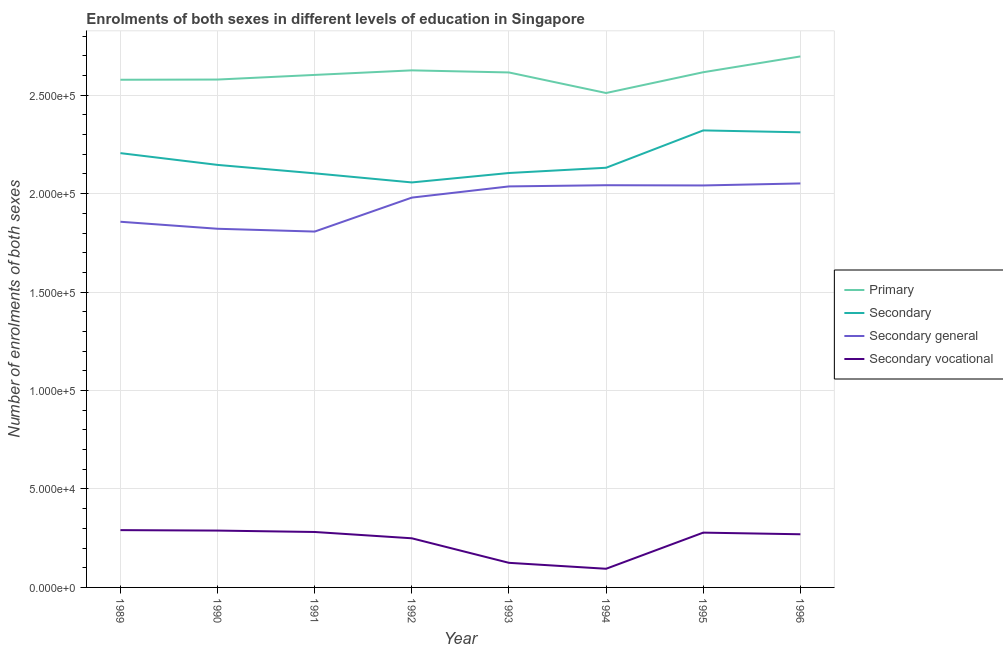Does the line corresponding to number of enrolments in secondary general education intersect with the line corresponding to number of enrolments in secondary education?
Keep it short and to the point. No. What is the number of enrolments in secondary vocational education in 1991?
Provide a succinct answer. 2.82e+04. Across all years, what is the maximum number of enrolments in primary education?
Keep it short and to the point. 2.70e+05. Across all years, what is the minimum number of enrolments in secondary vocational education?
Give a very brief answer. 9476. What is the total number of enrolments in secondary vocational education in the graph?
Provide a succinct answer. 1.88e+05. What is the difference between the number of enrolments in primary education in 1995 and that in 1996?
Offer a very short reply. -8020. What is the difference between the number of enrolments in primary education in 1991 and the number of enrolments in secondary vocational education in 1996?
Ensure brevity in your answer.  2.33e+05. What is the average number of enrolments in secondary general education per year?
Your answer should be compact. 1.95e+05. In the year 1996, what is the difference between the number of enrolments in secondary education and number of enrolments in secondary general education?
Ensure brevity in your answer.  2.60e+04. In how many years, is the number of enrolments in secondary education greater than 200000?
Offer a very short reply. 8. What is the ratio of the number of enrolments in secondary education in 1994 to that in 1995?
Ensure brevity in your answer.  0.92. What is the difference between the highest and the second highest number of enrolments in primary education?
Provide a short and direct response. 7069. What is the difference between the highest and the lowest number of enrolments in secondary education?
Provide a succinct answer. 2.64e+04. In how many years, is the number of enrolments in secondary general education greater than the average number of enrolments in secondary general education taken over all years?
Offer a terse response. 5. Is the sum of the number of enrolments in secondary education in 1990 and 1991 greater than the maximum number of enrolments in primary education across all years?
Provide a succinct answer. Yes. Is it the case that in every year, the sum of the number of enrolments in secondary general education and number of enrolments in secondary vocational education is greater than the sum of number of enrolments in primary education and number of enrolments in secondary education?
Provide a short and direct response. No. Does the number of enrolments in primary education monotonically increase over the years?
Provide a succinct answer. No. Is the number of enrolments in primary education strictly less than the number of enrolments in secondary general education over the years?
Keep it short and to the point. No. How many lines are there?
Provide a succinct answer. 4. How many years are there in the graph?
Provide a succinct answer. 8. Are the values on the major ticks of Y-axis written in scientific E-notation?
Provide a succinct answer. Yes. Does the graph contain any zero values?
Your answer should be very brief. No. Does the graph contain grids?
Make the answer very short. Yes. What is the title of the graph?
Give a very brief answer. Enrolments of both sexes in different levels of education in Singapore. Does "Regional development banks" appear as one of the legend labels in the graph?
Provide a short and direct response. No. What is the label or title of the X-axis?
Give a very brief answer. Year. What is the label or title of the Y-axis?
Provide a short and direct response. Number of enrolments of both sexes. What is the Number of enrolments of both sexes of Primary in 1989?
Give a very brief answer. 2.58e+05. What is the Number of enrolments of both sexes in Secondary in 1989?
Your response must be concise. 2.21e+05. What is the Number of enrolments of both sexes of Secondary general in 1989?
Provide a succinct answer. 1.86e+05. What is the Number of enrolments of both sexes in Secondary vocational in 1989?
Your answer should be compact. 2.91e+04. What is the Number of enrolments of both sexes in Primary in 1990?
Offer a very short reply. 2.58e+05. What is the Number of enrolments of both sexes of Secondary in 1990?
Provide a short and direct response. 2.15e+05. What is the Number of enrolments of both sexes of Secondary general in 1990?
Your response must be concise. 1.82e+05. What is the Number of enrolments of both sexes of Secondary vocational in 1990?
Offer a terse response. 2.89e+04. What is the Number of enrolments of both sexes in Primary in 1991?
Ensure brevity in your answer.  2.60e+05. What is the Number of enrolments of both sexes of Secondary in 1991?
Offer a terse response. 2.10e+05. What is the Number of enrolments of both sexes of Secondary general in 1991?
Make the answer very short. 1.81e+05. What is the Number of enrolments of both sexes of Secondary vocational in 1991?
Provide a succinct answer. 2.82e+04. What is the Number of enrolments of both sexes in Primary in 1992?
Your answer should be very brief. 2.63e+05. What is the Number of enrolments of both sexes in Secondary in 1992?
Offer a terse response. 2.06e+05. What is the Number of enrolments of both sexes of Secondary general in 1992?
Your response must be concise. 1.98e+05. What is the Number of enrolments of both sexes in Secondary vocational in 1992?
Provide a succinct answer. 2.50e+04. What is the Number of enrolments of both sexes of Primary in 1993?
Provide a short and direct response. 2.62e+05. What is the Number of enrolments of both sexes of Secondary in 1993?
Provide a short and direct response. 2.10e+05. What is the Number of enrolments of both sexes of Secondary general in 1993?
Provide a succinct answer. 2.04e+05. What is the Number of enrolments of both sexes of Secondary vocational in 1993?
Make the answer very short. 1.25e+04. What is the Number of enrolments of both sexes in Primary in 1994?
Make the answer very short. 2.51e+05. What is the Number of enrolments of both sexes in Secondary in 1994?
Provide a short and direct response. 2.13e+05. What is the Number of enrolments of both sexes in Secondary general in 1994?
Provide a succinct answer. 2.04e+05. What is the Number of enrolments of both sexes in Secondary vocational in 1994?
Your answer should be compact. 9476. What is the Number of enrolments of both sexes of Primary in 1995?
Your answer should be very brief. 2.62e+05. What is the Number of enrolments of both sexes of Secondary in 1995?
Ensure brevity in your answer.  2.32e+05. What is the Number of enrolments of both sexes of Secondary general in 1995?
Your response must be concise. 2.04e+05. What is the Number of enrolments of both sexes of Secondary vocational in 1995?
Keep it short and to the point. 2.78e+04. What is the Number of enrolments of both sexes in Primary in 1996?
Your answer should be very brief. 2.70e+05. What is the Number of enrolments of both sexes in Secondary in 1996?
Provide a short and direct response. 2.31e+05. What is the Number of enrolments of both sexes of Secondary general in 1996?
Give a very brief answer. 2.05e+05. What is the Number of enrolments of both sexes in Secondary vocational in 1996?
Offer a very short reply. 2.70e+04. Across all years, what is the maximum Number of enrolments of both sexes of Primary?
Ensure brevity in your answer.  2.70e+05. Across all years, what is the maximum Number of enrolments of both sexes of Secondary?
Keep it short and to the point. 2.32e+05. Across all years, what is the maximum Number of enrolments of both sexes in Secondary general?
Make the answer very short. 2.05e+05. Across all years, what is the maximum Number of enrolments of both sexes in Secondary vocational?
Ensure brevity in your answer.  2.91e+04. Across all years, what is the minimum Number of enrolments of both sexes in Primary?
Your answer should be very brief. 2.51e+05. Across all years, what is the minimum Number of enrolments of both sexes of Secondary?
Make the answer very short. 2.06e+05. Across all years, what is the minimum Number of enrolments of both sexes in Secondary general?
Your answer should be very brief. 1.81e+05. Across all years, what is the minimum Number of enrolments of both sexes in Secondary vocational?
Offer a terse response. 9476. What is the total Number of enrolments of both sexes in Primary in the graph?
Offer a very short reply. 2.08e+06. What is the total Number of enrolments of both sexes in Secondary in the graph?
Ensure brevity in your answer.  1.74e+06. What is the total Number of enrolments of both sexes in Secondary general in the graph?
Ensure brevity in your answer.  1.56e+06. What is the total Number of enrolments of both sexes in Secondary vocational in the graph?
Give a very brief answer. 1.88e+05. What is the difference between the Number of enrolments of both sexes of Primary in 1989 and that in 1990?
Ensure brevity in your answer.  -99. What is the difference between the Number of enrolments of both sexes in Secondary in 1989 and that in 1990?
Make the answer very short. 5977. What is the difference between the Number of enrolments of both sexes in Secondary general in 1989 and that in 1990?
Your answer should be very brief. 3564. What is the difference between the Number of enrolments of both sexes of Secondary vocational in 1989 and that in 1990?
Offer a terse response. 231. What is the difference between the Number of enrolments of both sexes of Primary in 1989 and that in 1991?
Offer a terse response. -2453. What is the difference between the Number of enrolments of both sexes of Secondary in 1989 and that in 1991?
Ensure brevity in your answer.  1.03e+04. What is the difference between the Number of enrolments of both sexes in Secondary general in 1989 and that in 1991?
Offer a very short reply. 4984. What is the difference between the Number of enrolments of both sexes of Secondary vocational in 1989 and that in 1991?
Offer a terse response. 947. What is the difference between the Number of enrolments of both sexes of Primary in 1989 and that in 1992?
Offer a terse response. -4766. What is the difference between the Number of enrolments of both sexes in Secondary in 1989 and that in 1992?
Keep it short and to the point. 1.49e+04. What is the difference between the Number of enrolments of both sexes in Secondary general in 1989 and that in 1992?
Provide a short and direct response. -1.23e+04. What is the difference between the Number of enrolments of both sexes in Secondary vocational in 1989 and that in 1992?
Your response must be concise. 4148. What is the difference between the Number of enrolments of both sexes in Primary in 1989 and that in 1993?
Provide a short and direct response. -3701. What is the difference between the Number of enrolments of both sexes of Secondary in 1989 and that in 1993?
Provide a short and direct response. 1.01e+04. What is the difference between the Number of enrolments of both sexes in Secondary general in 1989 and that in 1993?
Offer a very short reply. -1.79e+04. What is the difference between the Number of enrolments of both sexes of Secondary vocational in 1989 and that in 1993?
Provide a succinct answer. 1.66e+04. What is the difference between the Number of enrolments of both sexes in Primary in 1989 and that in 1994?
Your answer should be compact. 6736. What is the difference between the Number of enrolments of both sexes in Secondary in 1989 and that in 1994?
Keep it short and to the point. 7423. What is the difference between the Number of enrolments of both sexes of Secondary general in 1989 and that in 1994?
Offer a very short reply. -1.86e+04. What is the difference between the Number of enrolments of both sexes in Secondary vocational in 1989 and that in 1994?
Keep it short and to the point. 1.96e+04. What is the difference between the Number of enrolments of both sexes in Primary in 1989 and that in 1995?
Provide a succinct answer. -3815. What is the difference between the Number of enrolments of both sexes in Secondary in 1989 and that in 1995?
Offer a terse response. -1.15e+04. What is the difference between the Number of enrolments of both sexes in Secondary general in 1989 and that in 1995?
Your response must be concise. -1.84e+04. What is the difference between the Number of enrolments of both sexes in Secondary vocational in 1989 and that in 1995?
Offer a very short reply. 1271. What is the difference between the Number of enrolments of both sexes in Primary in 1989 and that in 1996?
Your answer should be compact. -1.18e+04. What is the difference between the Number of enrolments of both sexes of Secondary in 1989 and that in 1996?
Your response must be concise. -1.06e+04. What is the difference between the Number of enrolments of both sexes of Secondary general in 1989 and that in 1996?
Your answer should be compact. -1.95e+04. What is the difference between the Number of enrolments of both sexes of Secondary vocational in 1989 and that in 1996?
Your answer should be compact. 2104. What is the difference between the Number of enrolments of both sexes in Primary in 1990 and that in 1991?
Provide a succinct answer. -2354. What is the difference between the Number of enrolments of both sexes of Secondary in 1990 and that in 1991?
Provide a succinct answer. 4280. What is the difference between the Number of enrolments of both sexes of Secondary general in 1990 and that in 1991?
Keep it short and to the point. 1420. What is the difference between the Number of enrolments of both sexes of Secondary vocational in 1990 and that in 1991?
Provide a short and direct response. 716. What is the difference between the Number of enrolments of both sexes in Primary in 1990 and that in 1992?
Make the answer very short. -4667. What is the difference between the Number of enrolments of both sexes of Secondary in 1990 and that in 1992?
Your response must be concise. 8901. What is the difference between the Number of enrolments of both sexes of Secondary general in 1990 and that in 1992?
Your answer should be compact. -1.58e+04. What is the difference between the Number of enrolments of both sexes in Secondary vocational in 1990 and that in 1992?
Keep it short and to the point. 3917. What is the difference between the Number of enrolments of both sexes in Primary in 1990 and that in 1993?
Give a very brief answer. -3602. What is the difference between the Number of enrolments of both sexes in Secondary in 1990 and that in 1993?
Your answer should be compact. 4111. What is the difference between the Number of enrolments of both sexes in Secondary general in 1990 and that in 1993?
Keep it short and to the point. -2.15e+04. What is the difference between the Number of enrolments of both sexes in Secondary vocational in 1990 and that in 1993?
Provide a short and direct response. 1.64e+04. What is the difference between the Number of enrolments of both sexes of Primary in 1990 and that in 1994?
Your answer should be compact. 6835. What is the difference between the Number of enrolments of both sexes of Secondary in 1990 and that in 1994?
Provide a succinct answer. 1446. What is the difference between the Number of enrolments of both sexes of Secondary general in 1990 and that in 1994?
Your answer should be very brief. -2.21e+04. What is the difference between the Number of enrolments of both sexes in Secondary vocational in 1990 and that in 1994?
Give a very brief answer. 1.94e+04. What is the difference between the Number of enrolments of both sexes of Primary in 1990 and that in 1995?
Your answer should be very brief. -3716. What is the difference between the Number of enrolments of both sexes of Secondary in 1990 and that in 1995?
Ensure brevity in your answer.  -1.75e+04. What is the difference between the Number of enrolments of both sexes in Secondary general in 1990 and that in 1995?
Your response must be concise. -2.20e+04. What is the difference between the Number of enrolments of both sexes in Secondary vocational in 1990 and that in 1995?
Your response must be concise. 1040. What is the difference between the Number of enrolments of both sexes of Primary in 1990 and that in 1996?
Keep it short and to the point. -1.17e+04. What is the difference between the Number of enrolments of both sexes in Secondary in 1990 and that in 1996?
Keep it short and to the point. -1.66e+04. What is the difference between the Number of enrolments of both sexes of Secondary general in 1990 and that in 1996?
Make the answer very short. -2.30e+04. What is the difference between the Number of enrolments of both sexes in Secondary vocational in 1990 and that in 1996?
Offer a terse response. 1873. What is the difference between the Number of enrolments of both sexes in Primary in 1991 and that in 1992?
Provide a short and direct response. -2313. What is the difference between the Number of enrolments of both sexes of Secondary in 1991 and that in 1992?
Your response must be concise. 4621. What is the difference between the Number of enrolments of both sexes in Secondary general in 1991 and that in 1992?
Provide a short and direct response. -1.73e+04. What is the difference between the Number of enrolments of both sexes of Secondary vocational in 1991 and that in 1992?
Your answer should be compact. 3201. What is the difference between the Number of enrolments of both sexes in Primary in 1991 and that in 1993?
Your answer should be compact. -1248. What is the difference between the Number of enrolments of both sexes of Secondary in 1991 and that in 1993?
Offer a very short reply. -169. What is the difference between the Number of enrolments of both sexes of Secondary general in 1991 and that in 1993?
Offer a very short reply. -2.29e+04. What is the difference between the Number of enrolments of both sexes of Secondary vocational in 1991 and that in 1993?
Ensure brevity in your answer.  1.57e+04. What is the difference between the Number of enrolments of both sexes in Primary in 1991 and that in 1994?
Your answer should be compact. 9189. What is the difference between the Number of enrolments of both sexes of Secondary in 1991 and that in 1994?
Your answer should be very brief. -2834. What is the difference between the Number of enrolments of both sexes in Secondary general in 1991 and that in 1994?
Keep it short and to the point. -2.35e+04. What is the difference between the Number of enrolments of both sexes of Secondary vocational in 1991 and that in 1994?
Provide a short and direct response. 1.87e+04. What is the difference between the Number of enrolments of both sexes in Primary in 1991 and that in 1995?
Your answer should be compact. -1362. What is the difference between the Number of enrolments of both sexes in Secondary in 1991 and that in 1995?
Your answer should be very brief. -2.18e+04. What is the difference between the Number of enrolments of both sexes of Secondary general in 1991 and that in 1995?
Offer a terse response. -2.34e+04. What is the difference between the Number of enrolments of both sexes in Secondary vocational in 1991 and that in 1995?
Offer a very short reply. 324. What is the difference between the Number of enrolments of both sexes in Primary in 1991 and that in 1996?
Your answer should be very brief. -9382. What is the difference between the Number of enrolments of both sexes in Secondary in 1991 and that in 1996?
Your answer should be very brief. -2.08e+04. What is the difference between the Number of enrolments of both sexes in Secondary general in 1991 and that in 1996?
Ensure brevity in your answer.  -2.44e+04. What is the difference between the Number of enrolments of both sexes of Secondary vocational in 1991 and that in 1996?
Offer a terse response. 1157. What is the difference between the Number of enrolments of both sexes in Primary in 1992 and that in 1993?
Make the answer very short. 1065. What is the difference between the Number of enrolments of both sexes of Secondary in 1992 and that in 1993?
Offer a terse response. -4790. What is the difference between the Number of enrolments of both sexes of Secondary general in 1992 and that in 1993?
Provide a succinct answer. -5681. What is the difference between the Number of enrolments of both sexes in Secondary vocational in 1992 and that in 1993?
Provide a succinct answer. 1.25e+04. What is the difference between the Number of enrolments of both sexes in Primary in 1992 and that in 1994?
Offer a terse response. 1.15e+04. What is the difference between the Number of enrolments of both sexes in Secondary in 1992 and that in 1994?
Provide a succinct answer. -7455. What is the difference between the Number of enrolments of both sexes of Secondary general in 1992 and that in 1994?
Offer a very short reply. -6288. What is the difference between the Number of enrolments of both sexes of Secondary vocational in 1992 and that in 1994?
Keep it short and to the point. 1.55e+04. What is the difference between the Number of enrolments of both sexes in Primary in 1992 and that in 1995?
Your response must be concise. 951. What is the difference between the Number of enrolments of both sexes of Secondary in 1992 and that in 1995?
Provide a succinct answer. -2.64e+04. What is the difference between the Number of enrolments of both sexes in Secondary general in 1992 and that in 1995?
Give a very brief answer. -6165. What is the difference between the Number of enrolments of both sexes in Secondary vocational in 1992 and that in 1995?
Provide a short and direct response. -2877. What is the difference between the Number of enrolments of both sexes of Primary in 1992 and that in 1996?
Your answer should be compact. -7069. What is the difference between the Number of enrolments of both sexes in Secondary in 1992 and that in 1996?
Offer a terse response. -2.55e+04. What is the difference between the Number of enrolments of both sexes of Secondary general in 1992 and that in 1996?
Keep it short and to the point. -7190. What is the difference between the Number of enrolments of both sexes of Secondary vocational in 1992 and that in 1996?
Ensure brevity in your answer.  -2044. What is the difference between the Number of enrolments of both sexes of Primary in 1993 and that in 1994?
Your answer should be compact. 1.04e+04. What is the difference between the Number of enrolments of both sexes of Secondary in 1993 and that in 1994?
Give a very brief answer. -2665. What is the difference between the Number of enrolments of both sexes in Secondary general in 1993 and that in 1994?
Keep it short and to the point. -607. What is the difference between the Number of enrolments of both sexes of Secondary vocational in 1993 and that in 1994?
Your answer should be very brief. 3016. What is the difference between the Number of enrolments of both sexes of Primary in 1993 and that in 1995?
Offer a terse response. -114. What is the difference between the Number of enrolments of both sexes of Secondary in 1993 and that in 1995?
Offer a very short reply. -2.16e+04. What is the difference between the Number of enrolments of both sexes in Secondary general in 1993 and that in 1995?
Provide a short and direct response. -484. What is the difference between the Number of enrolments of both sexes of Secondary vocational in 1993 and that in 1995?
Offer a terse response. -1.53e+04. What is the difference between the Number of enrolments of both sexes of Primary in 1993 and that in 1996?
Make the answer very short. -8134. What is the difference between the Number of enrolments of both sexes of Secondary in 1993 and that in 1996?
Give a very brief answer. -2.07e+04. What is the difference between the Number of enrolments of both sexes in Secondary general in 1993 and that in 1996?
Offer a very short reply. -1509. What is the difference between the Number of enrolments of both sexes in Secondary vocational in 1993 and that in 1996?
Provide a succinct answer. -1.45e+04. What is the difference between the Number of enrolments of both sexes in Primary in 1994 and that in 1995?
Provide a short and direct response. -1.06e+04. What is the difference between the Number of enrolments of both sexes of Secondary in 1994 and that in 1995?
Offer a very short reply. -1.90e+04. What is the difference between the Number of enrolments of both sexes of Secondary general in 1994 and that in 1995?
Offer a terse response. 123. What is the difference between the Number of enrolments of both sexes in Secondary vocational in 1994 and that in 1995?
Provide a succinct answer. -1.84e+04. What is the difference between the Number of enrolments of both sexes of Primary in 1994 and that in 1996?
Offer a terse response. -1.86e+04. What is the difference between the Number of enrolments of both sexes of Secondary in 1994 and that in 1996?
Your answer should be very brief. -1.80e+04. What is the difference between the Number of enrolments of both sexes in Secondary general in 1994 and that in 1996?
Provide a short and direct response. -902. What is the difference between the Number of enrolments of both sexes in Secondary vocational in 1994 and that in 1996?
Ensure brevity in your answer.  -1.75e+04. What is the difference between the Number of enrolments of both sexes of Primary in 1995 and that in 1996?
Ensure brevity in your answer.  -8020. What is the difference between the Number of enrolments of both sexes in Secondary in 1995 and that in 1996?
Your answer should be very brief. 956. What is the difference between the Number of enrolments of both sexes in Secondary general in 1995 and that in 1996?
Offer a terse response. -1025. What is the difference between the Number of enrolments of both sexes in Secondary vocational in 1995 and that in 1996?
Your answer should be compact. 833. What is the difference between the Number of enrolments of both sexes of Primary in 1989 and the Number of enrolments of both sexes of Secondary in 1990?
Make the answer very short. 4.32e+04. What is the difference between the Number of enrolments of both sexes in Primary in 1989 and the Number of enrolments of both sexes in Secondary general in 1990?
Provide a succinct answer. 7.57e+04. What is the difference between the Number of enrolments of both sexes in Primary in 1989 and the Number of enrolments of both sexes in Secondary vocational in 1990?
Offer a very short reply. 2.29e+05. What is the difference between the Number of enrolments of both sexes of Secondary in 1989 and the Number of enrolments of both sexes of Secondary general in 1990?
Ensure brevity in your answer.  3.84e+04. What is the difference between the Number of enrolments of both sexes of Secondary in 1989 and the Number of enrolments of both sexes of Secondary vocational in 1990?
Ensure brevity in your answer.  1.92e+05. What is the difference between the Number of enrolments of both sexes of Secondary general in 1989 and the Number of enrolments of both sexes of Secondary vocational in 1990?
Offer a terse response. 1.57e+05. What is the difference between the Number of enrolments of both sexes of Primary in 1989 and the Number of enrolments of both sexes of Secondary in 1991?
Give a very brief answer. 4.75e+04. What is the difference between the Number of enrolments of both sexes in Primary in 1989 and the Number of enrolments of both sexes in Secondary general in 1991?
Provide a succinct answer. 7.71e+04. What is the difference between the Number of enrolments of both sexes of Primary in 1989 and the Number of enrolments of both sexes of Secondary vocational in 1991?
Give a very brief answer. 2.30e+05. What is the difference between the Number of enrolments of both sexes of Secondary in 1989 and the Number of enrolments of both sexes of Secondary general in 1991?
Provide a succinct answer. 3.98e+04. What is the difference between the Number of enrolments of both sexes in Secondary in 1989 and the Number of enrolments of both sexes in Secondary vocational in 1991?
Give a very brief answer. 1.92e+05. What is the difference between the Number of enrolments of both sexes in Secondary general in 1989 and the Number of enrolments of both sexes in Secondary vocational in 1991?
Your response must be concise. 1.58e+05. What is the difference between the Number of enrolments of both sexes in Primary in 1989 and the Number of enrolments of both sexes in Secondary in 1992?
Offer a very short reply. 5.22e+04. What is the difference between the Number of enrolments of both sexes in Primary in 1989 and the Number of enrolments of both sexes in Secondary general in 1992?
Your answer should be very brief. 5.99e+04. What is the difference between the Number of enrolments of both sexes of Primary in 1989 and the Number of enrolments of both sexes of Secondary vocational in 1992?
Provide a short and direct response. 2.33e+05. What is the difference between the Number of enrolments of both sexes of Secondary in 1989 and the Number of enrolments of both sexes of Secondary general in 1992?
Offer a very short reply. 2.26e+04. What is the difference between the Number of enrolments of both sexes in Secondary in 1989 and the Number of enrolments of both sexes in Secondary vocational in 1992?
Your response must be concise. 1.96e+05. What is the difference between the Number of enrolments of both sexes of Secondary general in 1989 and the Number of enrolments of both sexes of Secondary vocational in 1992?
Your answer should be very brief. 1.61e+05. What is the difference between the Number of enrolments of both sexes in Primary in 1989 and the Number of enrolments of both sexes in Secondary in 1993?
Provide a succinct answer. 4.74e+04. What is the difference between the Number of enrolments of both sexes in Primary in 1989 and the Number of enrolments of both sexes in Secondary general in 1993?
Your answer should be compact. 5.42e+04. What is the difference between the Number of enrolments of both sexes of Primary in 1989 and the Number of enrolments of both sexes of Secondary vocational in 1993?
Your answer should be very brief. 2.45e+05. What is the difference between the Number of enrolments of both sexes in Secondary in 1989 and the Number of enrolments of both sexes in Secondary general in 1993?
Offer a terse response. 1.69e+04. What is the difference between the Number of enrolments of both sexes in Secondary in 1989 and the Number of enrolments of both sexes in Secondary vocational in 1993?
Your response must be concise. 2.08e+05. What is the difference between the Number of enrolments of both sexes of Secondary general in 1989 and the Number of enrolments of both sexes of Secondary vocational in 1993?
Offer a very short reply. 1.73e+05. What is the difference between the Number of enrolments of both sexes in Primary in 1989 and the Number of enrolments of both sexes in Secondary in 1994?
Ensure brevity in your answer.  4.47e+04. What is the difference between the Number of enrolments of both sexes of Primary in 1989 and the Number of enrolments of both sexes of Secondary general in 1994?
Your response must be concise. 5.36e+04. What is the difference between the Number of enrolments of both sexes of Primary in 1989 and the Number of enrolments of both sexes of Secondary vocational in 1994?
Ensure brevity in your answer.  2.48e+05. What is the difference between the Number of enrolments of both sexes of Secondary in 1989 and the Number of enrolments of both sexes of Secondary general in 1994?
Ensure brevity in your answer.  1.63e+04. What is the difference between the Number of enrolments of both sexes in Secondary in 1989 and the Number of enrolments of both sexes in Secondary vocational in 1994?
Give a very brief answer. 2.11e+05. What is the difference between the Number of enrolments of both sexes in Secondary general in 1989 and the Number of enrolments of both sexes in Secondary vocational in 1994?
Offer a very short reply. 1.76e+05. What is the difference between the Number of enrolments of both sexes of Primary in 1989 and the Number of enrolments of both sexes of Secondary in 1995?
Offer a very short reply. 2.57e+04. What is the difference between the Number of enrolments of both sexes in Primary in 1989 and the Number of enrolments of both sexes in Secondary general in 1995?
Offer a very short reply. 5.37e+04. What is the difference between the Number of enrolments of both sexes of Primary in 1989 and the Number of enrolments of both sexes of Secondary vocational in 1995?
Provide a short and direct response. 2.30e+05. What is the difference between the Number of enrolments of both sexes of Secondary in 1989 and the Number of enrolments of both sexes of Secondary general in 1995?
Offer a terse response. 1.64e+04. What is the difference between the Number of enrolments of both sexes of Secondary in 1989 and the Number of enrolments of both sexes of Secondary vocational in 1995?
Provide a succinct answer. 1.93e+05. What is the difference between the Number of enrolments of both sexes in Secondary general in 1989 and the Number of enrolments of both sexes in Secondary vocational in 1995?
Provide a succinct answer. 1.58e+05. What is the difference between the Number of enrolments of both sexes in Primary in 1989 and the Number of enrolments of both sexes in Secondary in 1996?
Your answer should be very brief. 2.67e+04. What is the difference between the Number of enrolments of both sexes in Primary in 1989 and the Number of enrolments of both sexes in Secondary general in 1996?
Your response must be concise. 5.27e+04. What is the difference between the Number of enrolments of both sexes in Primary in 1989 and the Number of enrolments of both sexes in Secondary vocational in 1996?
Your response must be concise. 2.31e+05. What is the difference between the Number of enrolments of both sexes in Secondary in 1989 and the Number of enrolments of both sexes in Secondary general in 1996?
Your answer should be compact. 1.54e+04. What is the difference between the Number of enrolments of both sexes in Secondary in 1989 and the Number of enrolments of both sexes in Secondary vocational in 1996?
Offer a very short reply. 1.94e+05. What is the difference between the Number of enrolments of both sexes in Secondary general in 1989 and the Number of enrolments of both sexes in Secondary vocational in 1996?
Your answer should be very brief. 1.59e+05. What is the difference between the Number of enrolments of both sexes in Primary in 1990 and the Number of enrolments of both sexes in Secondary in 1991?
Give a very brief answer. 4.76e+04. What is the difference between the Number of enrolments of both sexes in Primary in 1990 and the Number of enrolments of both sexes in Secondary general in 1991?
Provide a succinct answer. 7.72e+04. What is the difference between the Number of enrolments of both sexes of Primary in 1990 and the Number of enrolments of both sexes of Secondary vocational in 1991?
Your response must be concise. 2.30e+05. What is the difference between the Number of enrolments of both sexes in Secondary in 1990 and the Number of enrolments of both sexes in Secondary general in 1991?
Your answer should be very brief. 3.39e+04. What is the difference between the Number of enrolments of both sexes in Secondary in 1990 and the Number of enrolments of both sexes in Secondary vocational in 1991?
Offer a terse response. 1.86e+05. What is the difference between the Number of enrolments of both sexes of Secondary general in 1990 and the Number of enrolments of both sexes of Secondary vocational in 1991?
Offer a terse response. 1.54e+05. What is the difference between the Number of enrolments of both sexes of Primary in 1990 and the Number of enrolments of both sexes of Secondary in 1992?
Give a very brief answer. 5.22e+04. What is the difference between the Number of enrolments of both sexes of Primary in 1990 and the Number of enrolments of both sexes of Secondary general in 1992?
Make the answer very short. 6.00e+04. What is the difference between the Number of enrolments of both sexes in Primary in 1990 and the Number of enrolments of both sexes in Secondary vocational in 1992?
Ensure brevity in your answer.  2.33e+05. What is the difference between the Number of enrolments of both sexes of Secondary in 1990 and the Number of enrolments of both sexes of Secondary general in 1992?
Your response must be concise. 1.66e+04. What is the difference between the Number of enrolments of both sexes in Secondary in 1990 and the Number of enrolments of both sexes in Secondary vocational in 1992?
Offer a terse response. 1.90e+05. What is the difference between the Number of enrolments of both sexes of Secondary general in 1990 and the Number of enrolments of both sexes of Secondary vocational in 1992?
Keep it short and to the point. 1.57e+05. What is the difference between the Number of enrolments of both sexes of Primary in 1990 and the Number of enrolments of both sexes of Secondary in 1993?
Make the answer very short. 4.75e+04. What is the difference between the Number of enrolments of both sexes in Primary in 1990 and the Number of enrolments of both sexes in Secondary general in 1993?
Offer a terse response. 5.43e+04. What is the difference between the Number of enrolments of both sexes in Primary in 1990 and the Number of enrolments of both sexes in Secondary vocational in 1993?
Keep it short and to the point. 2.45e+05. What is the difference between the Number of enrolments of both sexes in Secondary in 1990 and the Number of enrolments of both sexes in Secondary general in 1993?
Make the answer very short. 1.09e+04. What is the difference between the Number of enrolments of both sexes in Secondary in 1990 and the Number of enrolments of both sexes in Secondary vocational in 1993?
Ensure brevity in your answer.  2.02e+05. What is the difference between the Number of enrolments of both sexes in Secondary general in 1990 and the Number of enrolments of both sexes in Secondary vocational in 1993?
Your answer should be very brief. 1.70e+05. What is the difference between the Number of enrolments of both sexes in Primary in 1990 and the Number of enrolments of both sexes in Secondary in 1994?
Provide a short and direct response. 4.48e+04. What is the difference between the Number of enrolments of both sexes in Primary in 1990 and the Number of enrolments of both sexes in Secondary general in 1994?
Ensure brevity in your answer.  5.37e+04. What is the difference between the Number of enrolments of both sexes in Primary in 1990 and the Number of enrolments of both sexes in Secondary vocational in 1994?
Your answer should be very brief. 2.48e+05. What is the difference between the Number of enrolments of both sexes of Secondary in 1990 and the Number of enrolments of both sexes of Secondary general in 1994?
Your answer should be compact. 1.03e+04. What is the difference between the Number of enrolments of both sexes of Secondary in 1990 and the Number of enrolments of both sexes of Secondary vocational in 1994?
Offer a terse response. 2.05e+05. What is the difference between the Number of enrolments of both sexes in Secondary general in 1990 and the Number of enrolments of both sexes in Secondary vocational in 1994?
Make the answer very short. 1.73e+05. What is the difference between the Number of enrolments of both sexes in Primary in 1990 and the Number of enrolments of both sexes in Secondary in 1995?
Keep it short and to the point. 2.58e+04. What is the difference between the Number of enrolments of both sexes in Primary in 1990 and the Number of enrolments of both sexes in Secondary general in 1995?
Keep it short and to the point. 5.38e+04. What is the difference between the Number of enrolments of both sexes in Primary in 1990 and the Number of enrolments of both sexes in Secondary vocational in 1995?
Provide a short and direct response. 2.30e+05. What is the difference between the Number of enrolments of both sexes of Secondary in 1990 and the Number of enrolments of both sexes of Secondary general in 1995?
Make the answer very short. 1.04e+04. What is the difference between the Number of enrolments of both sexes of Secondary in 1990 and the Number of enrolments of both sexes of Secondary vocational in 1995?
Your answer should be very brief. 1.87e+05. What is the difference between the Number of enrolments of both sexes in Secondary general in 1990 and the Number of enrolments of both sexes in Secondary vocational in 1995?
Your answer should be compact. 1.54e+05. What is the difference between the Number of enrolments of both sexes of Primary in 1990 and the Number of enrolments of both sexes of Secondary in 1996?
Give a very brief answer. 2.68e+04. What is the difference between the Number of enrolments of both sexes in Primary in 1990 and the Number of enrolments of both sexes in Secondary general in 1996?
Keep it short and to the point. 5.28e+04. What is the difference between the Number of enrolments of both sexes in Primary in 1990 and the Number of enrolments of both sexes in Secondary vocational in 1996?
Your response must be concise. 2.31e+05. What is the difference between the Number of enrolments of both sexes in Secondary in 1990 and the Number of enrolments of both sexes in Secondary general in 1996?
Your answer should be very brief. 9413. What is the difference between the Number of enrolments of both sexes of Secondary in 1990 and the Number of enrolments of both sexes of Secondary vocational in 1996?
Provide a short and direct response. 1.88e+05. What is the difference between the Number of enrolments of both sexes in Secondary general in 1990 and the Number of enrolments of both sexes in Secondary vocational in 1996?
Provide a short and direct response. 1.55e+05. What is the difference between the Number of enrolments of both sexes of Primary in 1991 and the Number of enrolments of both sexes of Secondary in 1992?
Your answer should be compact. 5.46e+04. What is the difference between the Number of enrolments of both sexes in Primary in 1991 and the Number of enrolments of both sexes in Secondary general in 1992?
Ensure brevity in your answer.  6.23e+04. What is the difference between the Number of enrolments of both sexes of Primary in 1991 and the Number of enrolments of both sexes of Secondary vocational in 1992?
Ensure brevity in your answer.  2.35e+05. What is the difference between the Number of enrolments of both sexes in Secondary in 1991 and the Number of enrolments of both sexes in Secondary general in 1992?
Your answer should be compact. 1.23e+04. What is the difference between the Number of enrolments of both sexes in Secondary in 1991 and the Number of enrolments of both sexes in Secondary vocational in 1992?
Give a very brief answer. 1.85e+05. What is the difference between the Number of enrolments of both sexes of Secondary general in 1991 and the Number of enrolments of both sexes of Secondary vocational in 1992?
Offer a very short reply. 1.56e+05. What is the difference between the Number of enrolments of both sexes of Primary in 1991 and the Number of enrolments of both sexes of Secondary in 1993?
Make the answer very short. 4.98e+04. What is the difference between the Number of enrolments of both sexes of Primary in 1991 and the Number of enrolments of both sexes of Secondary general in 1993?
Offer a very short reply. 5.66e+04. What is the difference between the Number of enrolments of both sexes in Primary in 1991 and the Number of enrolments of both sexes in Secondary vocational in 1993?
Provide a short and direct response. 2.48e+05. What is the difference between the Number of enrolments of both sexes of Secondary in 1991 and the Number of enrolments of both sexes of Secondary general in 1993?
Keep it short and to the point. 6642. What is the difference between the Number of enrolments of both sexes of Secondary in 1991 and the Number of enrolments of both sexes of Secondary vocational in 1993?
Offer a terse response. 1.98e+05. What is the difference between the Number of enrolments of both sexes in Secondary general in 1991 and the Number of enrolments of both sexes in Secondary vocational in 1993?
Your answer should be very brief. 1.68e+05. What is the difference between the Number of enrolments of both sexes of Primary in 1991 and the Number of enrolments of both sexes of Secondary in 1994?
Your answer should be very brief. 4.71e+04. What is the difference between the Number of enrolments of both sexes in Primary in 1991 and the Number of enrolments of both sexes in Secondary general in 1994?
Ensure brevity in your answer.  5.60e+04. What is the difference between the Number of enrolments of both sexes in Primary in 1991 and the Number of enrolments of both sexes in Secondary vocational in 1994?
Your response must be concise. 2.51e+05. What is the difference between the Number of enrolments of both sexes of Secondary in 1991 and the Number of enrolments of both sexes of Secondary general in 1994?
Ensure brevity in your answer.  6035. What is the difference between the Number of enrolments of both sexes in Secondary in 1991 and the Number of enrolments of both sexes in Secondary vocational in 1994?
Provide a succinct answer. 2.01e+05. What is the difference between the Number of enrolments of both sexes in Secondary general in 1991 and the Number of enrolments of both sexes in Secondary vocational in 1994?
Make the answer very short. 1.71e+05. What is the difference between the Number of enrolments of both sexes in Primary in 1991 and the Number of enrolments of both sexes in Secondary in 1995?
Your response must be concise. 2.82e+04. What is the difference between the Number of enrolments of both sexes of Primary in 1991 and the Number of enrolments of both sexes of Secondary general in 1995?
Keep it short and to the point. 5.61e+04. What is the difference between the Number of enrolments of both sexes of Primary in 1991 and the Number of enrolments of both sexes of Secondary vocational in 1995?
Keep it short and to the point. 2.32e+05. What is the difference between the Number of enrolments of both sexes in Secondary in 1991 and the Number of enrolments of both sexes in Secondary general in 1995?
Provide a succinct answer. 6158. What is the difference between the Number of enrolments of both sexes in Secondary in 1991 and the Number of enrolments of both sexes in Secondary vocational in 1995?
Keep it short and to the point. 1.82e+05. What is the difference between the Number of enrolments of both sexes of Secondary general in 1991 and the Number of enrolments of both sexes of Secondary vocational in 1995?
Provide a succinct answer. 1.53e+05. What is the difference between the Number of enrolments of both sexes of Primary in 1991 and the Number of enrolments of both sexes of Secondary in 1996?
Your response must be concise. 2.91e+04. What is the difference between the Number of enrolments of both sexes of Primary in 1991 and the Number of enrolments of both sexes of Secondary general in 1996?
Make the answer very short. 5.51e+04. What is the difference between the Number of enrolments of both sexes in Primary in 1991 and the Number of enrolments of both sexes in Secondary vocational in 1996?
Make the answer very short. 2.33e+05. What is the difference between the Number of enrolments of both sexes of Secondary in 1991 and the Number of enrolments of both sexes of Secondary general in 1996?
Ensure brevity in your answer.  5133. What is the difference between the Number of enrolments of both sexes in Secondary in 1991 and the Number of enrolments of both sexes in Secondary vocational in 1996?
Make the answer very short. 1.83e+05. What is the difference between the Number of enrolments of both sexes of Secondary general in 1991 and the Number of enrolments of both sexes of Secondary vocational in 1996?
Your answer should be compact. 1.54e+05. What is the difference between the Number of enrolments of both sexes in Primary in 1992 and the Number of enrolments of both sexes in Secondary in 1993?
Provide a short and direct response. 5.21e+04. What is the difference between the Number of enrolments of both sexes of Primary in 1992 and the Number of enrolments of both sexes of Secondary general in 1993?
Keep it short and to the point. 5.89e+04. What is the difference between the Number of enrolments of both sexes in Primary in 1992 and the Number of enrolments of both sexes in Secondary vocational in 1993?
Make the answer very short. 2.50e+05. What is the difference between the Number of enrolments of both sexes of Secondary in 1992 and the Number of enrolments of both sexes of Secondary general in 1993?
Provide a short and direct response. 2021. What is the difference between the Number of enrolments of both sexes of Secondary in 1992 and the Number of enrolments of both sexes of Secondary vocational in 1993?
Offer a terse response. 1.93e+05. What is the difference between the Number of enrolments of both sexes of Secondary general in 1992 and the Number of enrolments of both sexes of Secondary vocational in 1993?
Your answer should be very brief. 1.85e+05. What is the difference between the Number of enrolments of both sexes of Primary in 1992 and the Number of enrolments of both sexes of Secondary in 1994?
Ensure brevity in your answer.  4.95e+04. What is the difference between the Number of enrolments of both sexes of Primary in 1992 and the Number of enrolments of both sexes of Secondary general in 1994?
Keep it short and to the point. 5.83e+04. What is the difference between the Number of enrolments of both sexes in Primary in 1992 and the Number of enrolments of both sexes in Secondary vocational in 1994?
Keep it short and to the point. 2.53e+05. What is the difference between the Number of enrolments of both sexes in Secondary in 1992 and the Number of enrolments of both sexes in Secondary general in 1994?
Keep it short and to the point. 1414. What is the difference between the Number of enrolments of both sexes of Secondary in 1992 and the Number of enrolments of both sexes of Secondary vocational in 1994?
Keep it short and to the point. 1.96e+05. What is the difference between the Number of enrolments of both sexes in Secondary general in 1992 and the Number of enrolments of both sexes in Secondary vocational in 1994?
Ensure brevity in your answer.  1.89e+05. What is the difference between the Number of enrolments of both sexes of Primary in 1992 and the Number of enrolments of both sexes of Secondary in 1995?
Give a very brief answer. 3.05e+04. What is the difference between the Number of enrolments of both sexes in Primary in 1992 and the Number of enrolments of both sexes in Secondary general in 1995?
Offer a very short reply. 5.85e+04. What is the difference between the Number of enrolments of both sexes of Primary in 1992 and the Number of enrolments of both sexes of Secondary vocational in 1995?
Give a very brief answer. 2.35e+05. What is the difference between the Number of enrolments of both sexes of Secondary in 1992 and the Number of enrolments of both sexes of Secondary general in 1995?
Ensure brevity in your answer.  1537. What is the difference between the Number of enrolments of both sexes of Secondary in 1992 and the Number of enrolments of both sexes of Secondary vocational in 1995?
Your answer should be compact. 1.78e+05. What is the difference between the Number of enrolments of both sexes in Secondary general in 1992 and the Number of enrolments of both sexes in Secondary vocational in 1995?
Provide a succinct answer. 1.70e+05. What is the difference between the Number of enrolments of both sexes in Primary in 1992 and the Number of enrolments of both sexes in Secondary in 1996?
Give a very brief answer. 3.15e+04. What is the difference between the Number of enrolments of both sexes of Primary in 1992 and the Number of enrolments of both sexes of Secondary general in 1996?
Give a very brief answer. 5.74e+04. What is the difference between the Number of enrolments of both sexes in Primary in 1992 and the Number of enrolments of both sexes in Secondary vocational in 1996?
Offer a terse response. 2.36e+05. What is the difference between the Number of enrolments of both sexes in Secondary in 1992 and the Number of enrolments of both sexes in Secondary general in 1996?
Ensure brevity in your answer.  512. What is the difference between the Number of enrolments of both sexes of Secondary in 1992 and the Number of enrolments of both sexes of Secondary vocational in 1996?
Make the answer very short. 1.79e+05. What is the difference between the Number of enrolments of both sexes in Secondary general in 1992 and the Number of enrolments of both sexes in Secondary vocational in 1996?
Offer a very short reply. 1.71e+05. What is the difference between the Number of enrolments of both sexes of Primary in 1993 and the Number of enrolments of both sexes of Secondary in 1994?
Keep it short and to the point. 4.84e+04. What is the difference between the Number of enrolments of both sexes in Primary in 1993 and the Number of enrolments of both sexes in Secondary general in 1994?
Keep it short and to the point. 5.73e+04. What is the difference between the Number of enrolments of both sexes in Primary in 1993 and the Number of enrolments of both sexes in Secondary vocational in 1994?
Keep it short and to the point. 2.52e+05. What is the difference between the Number of enrolments of both sexes in Secondary in 1993 and the Number of enrolments of both sexes in Secondary general in 1994?
Give a very brief answer. 6204. What is the difference between the Number of enrolments of both sexes in Secondary in 1993 and the Number of enrolments of both sexes in Secondary vocational in 1994?
Provide a succinct answer. 2.01e+05. What is the difference between the Number of enrolments of both sexes in Secondary general in 1993 and the Number of enrolments of both sexes in Secondary vocational in 1994?
Offer a terse response. 1.94e+05. What is the difference between the Number of enrolments of both sexes of Primary in 1993 and the Number of enrolments of both sexes of Secondary in 1995?
Your answer should be compact. 2.94e+04. What is the difference between the Number of enrolments of both sexes of Primary in 1993 and the Number of enrolments of both sexes of Secondary general in 1995?
Make the answer very short. 5.74e+04. What is the difference between the Number of enrolments of both sexes in Primary in 1993 and the Number of enrolments of both sexes in Secondary vocational in 1995?
Make the answer very short. 2.34e+05. What is the difference between the Number of enrolments of both sexes in Secondary in 1993 and the Number of enrolments of both sexes in Secondary general in 1995?
Make the answer very short. 6327. What is the difference between the Number of enrolments of both sexes of Secondary in 1993 and the Number of enrolments of both sexes of Secondary vocational in 1995?
Your response must be concise. 1.83e+05. What is the difference between the Number of enrolments of both sexes in Secondary general in 1993 and the Number of enrolments of both sexes in Secondary vocational in 1995?
Your answer should be very brief. 1.76e+05. What is the difference between the Number of enrolments of both sexes of Primary in 1993 and the Number of enrolments of both sexes of Secondary in 1996?
Provide a short and direct response. 3.04e+04. What is the difference between the Number of enrolments of both sexes of Primary in 1993 and the Number of enrolments of both sexes of Secondary general in 1996?
Offer a terse response. 5.64e+04. What is the difference between the Number of enrolments of both sexes in Primary in 1993 and the Number of enrolments of both sexes in Secondary vocational in 1996?
Provide a succinct answer. 2.35e+05. What is the difference between the Number of enrolments of both sexes in Secondary in 1993 and the Number of enrolments of both sexes in Secondary general in 1996?
Your response must be concise. 5302. What is the difference between the Number of enrolments of both sexes in Secondary in 1993 and the Number of enrolments of both sexes in Secondary vocational in 1996?
Provide a short and direct response. 1.83e+05. What is the difference between the Number of enrolments of both sexes of Secondary general in 1993 and the Number of enrolments of both sexes of Secondary vocational in 1996?
Give a very brief answer. 1.77e+05. What is the difference between the Number of enrolments of both sexes of Primary in 1994 and the Number of enrolments of both sexes of Secondary in 1995?
Keep it short and to the point. 1.90e+04. What is the difference between the Number of enrolments of both sexes in Primary in 1994 and the Number of enrolments of both sexes in Secondary general in 1995?
Your response must be concise. 4.70e+04. What is the difference between the Number of enrolments of both sexes in Primary in 1994 and the Number of enrolments of both sexes in Secondary vocational in 1995?
Your answer should be compact. 2.23e+05. What is the difference between the Number of enrolments of both sexes in Secondary in 1994 and the Number of enrolments of both sexes in Secondary general in 1995?
Your answer should be very brief. 8992. What is the difference between the Number of enrolments of both sexes in Secondary in 1994 and the Number of enrolments of both sexes in Secondary vocational in 1995?
Your answer should be very brief. 1.85e+05. What is the difference between the Number of enrolments of both sexes of Secondary general in 1994 and the Number of enrolments of both sexes of Secondary vocational in 1995?
Your response must be concise. 1.76e+05. What is the difference between the Number of enrolments of both sexes in Primary in 1994 and the Number of enrolments of both sexes in Secondary in 1996?
Provide a short and direct response. 2.00e+04. What is the difference between the Number of enrolments of both sexes of Primary in 1994 and the Number of enrolments of both sexes of Secondary general in 1996?
Give a very brief answer. 4.59e+04. What is the difference between the Number of enrolments of both sexes in Primary in 1994 and the Number of enrolments of both sexes in Secondary vocational in 1996?
Ensure brevity in your answer.  2.24e+05. What is the difference between the Number of enrolments of both sexes in Secondary in 1994 and the Number of enrolments of both sexes in Secondary general in 1996?
Your answer should be very brief. 7967. What is the difference between the Number of enrolments of both sexes in Secondary in 1994 and the Number of enrolments of both sexes in Secondary vocational in 1996?
Offer a terse response. 1.86e+05. What is the difference between the Number of enrolments of both sexes in Secondary general in 1994 and the Number of enrolments of both sexes in Secondary vocational in 1996?
Your answer should be very brief. 1.77e+05. What is the difference between the Number of enrolments of both sexes in Primary in 1995 and the Number of enrolments of both sexes in Secondary in 1996?
Offer a terse response. 3.05e+04. What is the difference between the Number of enrolments of both sexes in Primary in 1995 and the Number of enrolments of both sexes in Secondary general in 1996?
Give a very brief answer. 5.65e+04. What is the difference between the Number of enrolments of both sexes in Primary in 1995 and the Number of enrolments of both sexes in Secondary vocational in 1996?
Offer a very short reply. 2.35e+05. What is the difference between the Number of enrolments of both sexes of Secondary in 1995 and the Number of enrolments of both sexes of Secondary general in 1996?
Offer a terse response. 2.69e+04. What is the difference between the Number of enrolments of both sexes in Secondary in 1995 and the Number of enrolments of both sexes in Secondary vocational in 1996?
Your response must be concise. 2.05e+05. What is the difference between the Number of enrolments of both sexes of Secondary general in 1995 and the Number of enrolments of both sexes of Secondary vocational in 1996?
Keep it short and to the point. 1.77e+05. What is the average Number of enrolments of both sexes in Primary per year?
Offer a terse response. 2.60e+05. What is the average Number of enrolments of both sexes of Secondary per year?
Keep it short and to the point. 2.17e+05. What is the average Number of enrolments of both sexes of Secondary general per year?
Keep it short and to the point. 1.95e+05. What is the average Number of enrolments of both sexes in Secondary vocational per year?
Make the answer very short. 2.35e+04. In the year 1989, what is the difference between the Number of enrolments of both sexes of Primary and Number of enrolments of both sexes of Secondary?
Your answer should be very brief. 3.73e+04. In the year 1989, what is the difference between the Number of enrolments of both sexes of Primary and Number of enrolments of both sexes of Secondary general?
Make the answer very short. 7.21e+04. In the year 1989, what is the difference between the Number of enrolments of both sexes in Primary and Number of enrolments of both sexes in Secondary vocational?
Provide a succinct answer. 2.29e+05. In the year 1989, what is the difference between the Number of enrolments of both sexes in Secondary and Number of enrolments of both sexes in Secondary general?
Ensure brevity in your answer.  3.48e+04. In the year 1989, what is the difference between the Number of enrolments of both sexes of Secondary and Number of enrolments of both sexes of Secondary vocational?
Offer a terse response. 1.91e+05. In the year 1989, what is the difference between the Number of enrolments of both sexes of Secondary general and Number of enrolments of both sexes of Secondary vocational?
Offer a very short reply. 1.57e+05. In the year 1990, what is the difference between the Number of enrolments of both sexes of Primary and Number of enrolments of both sexes of Secondary?
Your answer should be very brief. 4.33e+04. In the year 1990, what is the difference between the Number of enrolments of both sexes of Primary and Number of enrolments of both sexes of Secondary general?
Offer a terse response. 7.58e+04. In the year 1990, what is the difference between the Number of enrolments of both sexes in Primary and Number of enrolments of both sexes in Secondary vocational?
Your answer should be very brief. 2.29e+05. In the year 1990, what is the difference between the Number of enrolments of both sexes of Secondary and Number of enrolments of both sexes of Secondary general?
Your answer should be very brief. 3.24e+04. In the year 1990, what is the difference between the Number of enrolments of both sexes in Secondary and Number of enrolments of both sexes in Secondary vocational?
Keep it short and to the point. 1.86e+05. In the year 1990, what is the difference between the Number of enrolments of both sexes of Secondary general and Number of enrolments of both sexes of Secondary vocational?
Keep it short and to the point. 1.53e+05. In the year 1991, what is the difference between the Number of enrolments of both sexes in Primary and Number of enrolments of both sexes in Secondary?
Make the answer very short. 5.00e+04. In the year 1991, what is the difference between the Number of enrolments of both sexes in Primary and Number of enrolments of both sexes in Secondary general?
Offer a very short reply. 7.96e+04. In the year 1991, what is the difference between the Number of enrolments of both sexes of Primary and Number of enrolments of both sexes of Secondary vocational?
Make the answer very short. 2.32e+05. In the year 1991, what is the difference between the Number of enrolments of both sexes of Secondary and Number of enrolments of both sexes of Secondary general?
Provide a succinct answer. 2.96e+04. In the year 1991, what is the difference between the Number of enrolments of both sexes of Secondary and Number of enrolments of both sexes of Secondary vocational?
Provide a succinct answer. 1.82e+05. In the year 1991, what is the difference between the Number of enrolments of both sexes of Secondary general and Number of enrolments of both sexes of Secondary vocational?
Offer a terse response. 1.53e+05. In the year 1992, what is the difference between the Number of enrolments of both sexes of Primary and Number of enrolments of both sexes of Secondary?
Make the answer very short. 5.69e+04. In the year 1992, what is the difference between the Number of enrolments of both sexes of Primary and Number of enrolments of both sexes of Secondary general?
Provide a short and direct response. 6.46e+04. In the year 1992, what is the difference between the Number of enrolments of both sexes of Primary and Number of enrolments of both sexes of Secondary vocational?
Provide a succinct answer. 2.38e+05. In the year 1992, what is the difference between the Number of enrolments of both sexes of Secondary and Number of enrolments of both sexes of Secondary general?
Keep it short and to the point. 7702. In the year 1992, what is the difference between the Number of enrolments of both sexes in Secondary and Number of enrolments of both sexes in Secondary vocational?
Your answer should be very brief. 1.81e+05. In the year 1992, what is the difference between the Number of enrolments of both sexes in Secondary general and Number of enrolments of both sexes in Secondary vocational?
Provide a short and direct response. 1.73e+05. In the year 1993, what is the difference between the Number of enrolments of both sexes of Primary and Number of enrolments of both sexes of Secondary?
Your answer should be compact. 5.11e+04. In the year 1993, what is the difference between the Number of enrolments of both sexes in Primary and Number of enrolments of both sexes in Secondary general?
Provide a short and direct response. 5.79e+04. In the year 1993, what is the difference between the Number of enrolments of both sexes of Primary and Number of enrolments of both sexes of Secondary vocational?
Give a very brief answer. 2.49e+05. In the year 1993, what is the difference between the Number of enrolments of both sexes in Secondary and Number of enrolments of both sexes in Secondary general?
Offer a very short reply. 6811. In the year 1993, what is the difference between the Number of enrolments of both sexes in Secondary and Number of enrolments of both sexes in Secondary vocational?
Your response must be concise. 1.98e+05. In the year 1993, what is the difference between the Number of enrolments of both sexes in Secondary general and Number of enrolments of both sexes in Secondary vocational?
Give a very brief answer. 1.91e+05. In the year 1994, what is the difference between the Number of enrolments of both sexes in Primary and Number of enrolments of both sexes in Secondary?
Provide a short and direct response. 3.80e+04. In the year 1994, what is the difference between the Number of enrolments of both sexes in Primary and Number of enrolments of both sexes in Secondary general?
Keep it short and to the point. 4.68e+04. In the year 1994, what is the difference between the Number of enrolments of both sexes in Primary and Number of enrolments of both sexes in Secondary vocational?
Your answer should be compact. 2.42e+05. In the year 1994, what is the difference between the Number of enrolments of both sexes of Secondary and Number of enrolments of both sexes of Secondary general?
Make the answer very short. 8869. In the year 1994, what is the difference between the Number of enrolments of both sexes of Secondary and Number of enrolments of both sexes of Secondary vocational?
Make the answer very short. 2.04e+05. In the year 1994, what is the difference between the Number of enrolments of both sexes in Secondary general and Number of enrolments of both sexes in Secondary vocational?
Offer a very short reply. 1.95e+05. In the year 1995, what is the difference between the Number of enrolments of both sexes of Primary and Number of enrolments of both sexes of Secondary?
Make the answer very short. 2.95e+04. In the year 1995, what is the difference between the Number of enrolments of both sexes in Primary and Number of enrolments of both sexes in Secondary general?
Provide a short and direct response. 5.75e+04. In the year 1995, what is the difference between the Number of enrolments of both sexes in Primary and Number of enrolments of both sexes in Secondary vocational?
Your answer should be compact. 2.34e+05. In the year 1995, what is the difference between the Number of enrolments of both sexes in Secondary and Number of enrolments of both sexes in Secondary general?
Offer a very short reply. 2.80e+04. In the year 1995, what is the difference between the Number of enrolments of both sexes in Secondary and Number of enrolments of both sexes in Secondary vocational?
Make the answer very short. 2.04e+05. In the year 1995, what is the difference between the Number of enrolments of both sexes of Secondary general and Number of enrolments of both sexes of Secondary vocational?
Offer a very short reply. 1.76e+05. In the year 1996, what is the difference between the Number of enrolments of both sexes of Primary and Number of enrolments of both sexes of Secondary?
Offer a very short reply. 3.85e+04. In the year 1996, what is the difference between the Number of enrolments of both sexes in Primary and Number of enrolments of both sexes in Secondary general?
Provide a short and direct response. 6.45e+04. In the year 1996, what is the difference between the Number of enrolments of both sexes of Primary and Number of enrolments of both sexes of Secondary vocational?
Your answer should be very brief. 2.43e+05. In the year 1996, what is the difference between the Number of enrolments of both sexes of Secondary and Number of enrolments of both sexes of Secondary general?
Provide a short and direct response. 2.60e+04. In the year 1996, what is the difference between the Number of enrolments of both sexes in Secondary and Number of enrolments of both sexes in Secondary vocational?
Provide a succinct answer. 2.04e+05. In the year 1996, what is the difference between the Number of enrolments of both sexes in Secondary general and Number of enrolments of both sexes in Secondary vocational?
Provide a succinct answer. 1.78e+05. What is the ratio of the Number of enrolments of both sexes in Primary in 1989 to that in 1990?
Your answer should be very brief. 1. What is the ratio of the Number of enrolments of both sexes in Secondary in 1989 to that in 1990?
Your answer should be very brief. 1.03. What is the ratio of the Number of enrolments of both sexes of Secondary general in 1989 to that in 1990?
Make the answer very short. 1.02. What is the ratio of the Number of enrolments of both sexes of Secondary vocational in 1989 to that in 1990?
Ensure brevity in your answer.  1.01. What is the ratio of the Number of enrolments of both sexes in Primary in 1989 to that in 1991?
Offer a terse response. 0.99. What is the ratio of the Number of enrolments of both sexes of Secondary in 1989 to that in 1991?
Keep it short and to the point. 1.05. What is the ratio of the Number of enrolments of both sexes of Secondary general in 1989 to that in 1991?
Offer a terse response. 1.03. What is the ratio of the Number of enrolments of both sexes in Secondary vocational in 1989 to that in 1991?
Offer a terse response. 1.03. What is the ratio of the Number of enrolments of both sexes in Primary in 1989 to that in 1992?
Your answer should be very brief. 0.98. What is the ratio of the Number of enrolments of both sexes of Secondary in 1989 to that in 1992?
Provide a succinct answer. 1.07. What is the ratio of the Number of enrolments of both sexes in Secondary general in 1989 to that in 1992?
Offer a very short reply. 0.94. What is the ratio of the Number of enrolments of both sexes of Secondary vocational in 1989 to that in 1992?
Give a very brief answer. 1.17. What is the ratio of the Number of enrolments of both sexes in Primary in 1989 to that in 1993?
Provide a short and direct response. 0.99. What is the ratio of the Number of enrolments of both sexes in Secondary in 1989 to that in 1993?
Provide a short and direct response. 1.05. What is the ratio of the Number of enrolments of both sexes in Secondary general in 1989 to that in 1993?
Your response must be concise. 0.91. What is the ratio of the Number of enrolments of both sexes of Secondary vocational in 1989 to that in 1993?
Ensure brevity in your answer.  2.33. What is the ratio of the Number of enrolments of both sexes of Primary in 1989 to that in 1994?
Keep it short and to the point. 1.03. What is the ratio of the Number of enrolments of both sexes of Secondary in 1989 to that in 1994?
Your answer should be very brief. 1.03. What is the ratio of the Number of enrolments of both sexes of Secondary general in 1989 to that in 1994?
Offer a terse response. 0.91. What is the ratio of the Number of enrolments of both sexes in Secondary vocational in 1989 to that in 1994?
Make the answer very short. 3.07. What is the ratio of the Number of enrolments of both sexes in Primary in 1989 to that in 1995?
Make the answer very short. 0.99. What is the ratio of the Number of enrolments of both sexes in Secondary in 1989 to that in 1995?
Your answer should be compact. 0.95. What is the ratio of the Number of enrolments of both sexes of Secondary general in 1989 to that in 1995?
Your answer should be very brief. 0.91. What is the ratio of the Number of enrolments of both sexes of Secondary vocational in 1989 to that in 1995?
Offer a very short reply. 1.05. What is the ratio of the Number of enrolments of both sexes in Primary in 1989 to that in 1996?
Offer a very short reply. 0.96. What is the ratio of the Number of enrolments of both sexes in Secondary in 1989 to that in 1996?
Your response must be concise. 0.95. What is the ratio of the Number of enrolments of both sexes in Secondary general in 1989 to that in 1996?
Your response must be concise. 0.91. What is the ratio of the Number of enrolments of both sexes in Secondary vocational in 1989 to that in 1996?
Give a very brief answer. 1.08. What is the ratio of the Number of enrolments of both sexes in Primary in 1990 to that in 1991?
Provide a short and direct response. 0.99. What is the ratio of the Number of enrolments of both sexes of Secondary in 1990 to that in 1991?
Provide a short and direct response. 1.02. What is the ratio of the Number of enrolments of both sexes of Secondary general in 1990 to that in 1991?
Keep it short and to the point. 1.01. What is the ratio of the Number of enrolments of both sexes in Secondary vocational in 1990 to that in 1991?
Offer a terse response. 1.03. What is the ratio of the Number of enrolments of both sexes in Primary in 1990 to that in 1992?
Make the answer very short. 0.98. What is the ratio of the Number of enrolments of both sexes in Secondary in 1990 to that in 1992?
Your answer should be compact. 1.04. What is the ratio of the Number of enrolments of both sexes of Secondary general in 1990 to that in 1992?
Offer a very short reply. 0.92. What is the ratio of the Number of enrolments of both sexes in Secondary vocational in 1990 to that in 1992?
Provide a succinct answer. 1.16. What is the ratio of the Number of enrolments of both sexes in Primary in 1990 to that in 1993?
Keep it short and to the point. 0.99. What is the ratio of the Number of enrolments of both sexes of Secondary in 1990 to that in 1993?
Keep it short and to the point. 1.02. What is the ratio of the Number of enrolments of both sexes in Secondary general in 1990 to that in 1993?
Offer a very short reply. 0.89. What is the ratio of the Number of enrolments of both sexes in Secondary vocational in 1990 to that in 1993?
Keep it short and to the point. 2.31. What is the ratio of the Number of enrolments of both sexes of Primary in 1990 to that in 1994?
Provide a succinct answer. 1.03. What is the ratio of the Number of enrolments of both sexes of Secondary in 1990 to that in 1994?
Give a very brief answer. 1.01. What is the ratio of the Number of enrolments of both sexes of Secondary general in 1990 to that in 1994?
Offer a very short reply. 0.89. What is the ratio of the Number of enrolments of both sexes of Secondary vocational in 1990 to that in 1994?
Provide a short and direct response. 3.05. What is the ratio of the Number of enrolments of both sexes in Primary in 1990 to that in 1995?
Your response must be concise. 0.99. What is the ratio of the Number of enrolments of both sexes in Secondary in 1990 to that in 1995?
Make the answer very short. 0.92. What is the ratio of the Number of enrolments of both sexes of Secondary general in 1990 to that in 1995?
Your answer should be compact. 0.89. What is the ratio of the Number of enrolments of both sexes of Secondary vocational in 1990 to that in 1995?
Provide a short and direct response. 1.04. What is the ratio of the Number of enrolments of both sexes in Primary in 1990 to that in 1996?
Offer a very short reply. 0.96. What is the ratio of the Number of enrolments of both sexes of Secondary in 1990 to that in 1996?
Give a very brief answer. 0.93. What is the ratio of the Number of enrolments of both sexes in Secondary general in 1990 to that in 1996?
Ensure brevity in your answer.  0.89. What is the ratio of the Number of enrolments of both sexes in Secondary vocational in 1990 to that in 1996?
Ensure brevity in your answer.  1.07. What is the ratio of the Number of enrolments of both sexes of Primary in 1991 to that in 1992?
Give a very brief answer. 0.99. What is the ratio of the Number of enrolments of both sexes of Secondary in 1991 to that in 1992?
Your response must be concise. 1.02. What is the ratio of the Number of enrolments of both sexes of Secondary general in 1991 to that in 1992?
Your answer should be compact. 0.91. What is the ratio of the Number of enrolments of both sexes of Secondary vocational in 1991 to that in 1992?
Keep it short and to the point. 1.13. What is the ratio of the Number of enrolments of both sexes in Secondary in 1991 to that in 1993?
Your answer should be compact. 1. What is the ratio of the Number of enrolments of both sexes of Secondary general in 1991 to that in 1993?
Your answer should be compact. 0.89. What is the ratio of the Number of enrolments of both sexes in Secondary vocational in 1991 to that in 1993?
Offer a very short reply. 2.25. What is the ratio of the Number of enrolments of both sexes of Primary in 1991 to that in 1994?
Offer a terse response. 1.04. What is the ratio of the Number of enrolments of both sexes in Secondary in 1991 to that in 1994?
Offer a terse response. 0.99. What is the ratio of the Number of enrolments of both sexes of Secondary general in 1991 to that in 1994?
Your answer should be compact. 0.88. What is the ratio of the Number of enrolments of both sexes in Secondary vocational in 1991 to that in 1994?
Make the answer very short. 2.97. What is the ratio of the Number of enrolments of both sexes of Secondary in 1991 to that in 1995?
Make the answer very short. 0.91. What is the ratio of the Number of enrolments of both sexes in Secondary general in 1991 to that in 1995?
Keep it short and to the point. 0.89. What is the ratio of the Number of enrolments of both sexes of Secondary vocational in 1991 to that in 1995?
Ensure brevity in your answer.  1.01. What is the ratio of the Number of enrolments of both sexes of Primary in 1991 to that in 1996?
Your response must be concise. 0.97. What is the ratio of the Number of enrolments of both sexes of Secondary in 1991 to that in 1996?
Provide a short and direct response. 0.91. What is the ratio of the Number of enrolments of both sexes of Secondary general in 1991 to that in 1996?
Provide a short and direct response. 0.88. What is the ratio of the Number of enrolments of both sexes of Secondary vocational in 1991 to that in 1996?
Provide a short and direct response. 1.04. What is the ratio of the Number of enrolments of both sexes of Primary in 1992 to that in 1993?
Give a very brief answer. 1. What is the ratio of the Number of enrolments of both sexes of Secondary in 1992 to that in 1993?
Your answer should be very brief. 0.98. What is the ratio of the Number of enrolments of both sexes in Secondary general in 1992 to that in 1993?
Give a very brief answer. 0.97. What is the ratio of the Number of enrolments of both sexes of Secondary vocational in 1992 to that in 1993?
Keep it short and to the point. 2. What is the ratio of the Number of enrolments of both sexes in Primary in 1992 to that in 1994?
Your answer should be very brief. 1.05. What is the ratio of the Number of enrolments of both sexes in Secondary general in 1992 to that in 1994?
Ensure brevity in your answer.  0.97. What is the ratio of the Number of enrolments of both sexes of Secondary vocational in 1992 to that in 1994?
Make the answer very short. 2.63. What is the ratio of the Number of enrolments of both sexes in Primary in 1992 to that in 1995?
Offer a very short reply. 1. What is the ratio of the Number of enrolments of both sexes in Secondary in 1992 to that in 1995?
Make the answer very short. 0.89. What is the ratio of the Number of enrolments of both sexes of Secondary general in 1992 to that in 1995?
Ensure brevity in your answer.  0.97. What is the ratio of the Number of enrolments of both sexes of Secondary vocational in 1992 to that in 1995?
Your answer should be very brief. 0.9. What is the ratio of the Number of enrolments of both sexes of Primary in 1992 to that in 1996?
Give a very brief answer. 0.97. What is the ratio of the Number of enrolments of both sexes in Secondary in 1992 to that in 1996?
Provide a succinct answer. 0.89. What is the ratio of the Number of enrolments of both sexes in Secondary general in 1992 to that in 1996?
Your answer should be very brief. 0.96. What is the ratio of the Number of enrolments of both sexes in Secondary vocational in 1992 to that in 1996?
Your answer should be very brief. 0.92. What is the ratio of the Number of enrolments of both sexes in Primary in 1993 to that in 1994?
Provide a succinct answer. 1.04. What is the ratio of the Number of enrolments of both sexes in Secondary in 1993 to that in 1994?
Ensure brevity in your answer.  0.99. What is the ratio of the Number of enrolments of both sexes of Secondary general in 1993 to that in 1994?
Ensure brevity in your answer.  1. What is the ratio of the Number of enrolments of both sexes of Secondary vocational in 1993 to that in 1994?
Offer a very short reply. 1.32. What is the ratio of the Number of enrolments of both sexes of Primary in 1993 to that in 1995?
Your answer should be compact. 1. What is the ratio of the Number of enrolments of both sexes in Secondary in 1993 to that in 1995?
Your response must be concise. 0.91. What is the ratio of the Number of enrolments of both sexes of Secondary general in 1993 to that in 1995?
Provide a succinct answer. 1. What is the ratio of the Number of enrolments of both sexes of Secondary vocational in 1993 to that in 1995?
Keep it short and to the point. 0.45. What is the ratio of the Number of enrolments of both sexes of Primary in 1993 to that in 1996?
Provide a succinct answer. 0.97. What is the ratio of the Number of enrolments of both sexes of Secondary in 1993 to that in 1996?
Offer a terse response. 0.91. What is the ratio of the Number of enrolments of both sexes in Secondary vocational in 1993 to that in 1996?
Your response must be concise. 0.46. What is the ratio of the Number of enrolments of both sexes of Primary in 1994 to that in 1995?
Your answer should be compact. 0.96. What is the ratio of the Number of enrolments of both sexes in Secondary in 1994 to that in 1995?
Your response must be concise. 0.92. What is the ratio of the Number of enrolments of both sexes in Secondary vocational in 1994 to that in 1995?
Provide a short and direct response. 0.34. What is the ratio of the Number of enrolments of both sexes of Primary in 1994 to that in 1996?
Provide a short and direct response. 0.93. What is the ratio of the Number of enrolments of both sexes in Secondary in 1994 to that in 1996?
Ensure brevity in your answer.  0.92. What is the ratio of the Number of enrolments of both sexes of Secondary vocational in 1994 to that in 1996?
Make the answer very short. 0.35. What is the ratio of the Number of enrolments of both sexes of Primary in 1995 to that in 1996?
Offer a terse response. 0.97. What is the ratio of the Number of enrolments of both sexes of Secondary general in 1995 to that in 1996?
Provide a short and direct response. 0.99. What is the ratio of the Number of enrolments of both sexes of Secondary vocational in 1995 to that in 1996?
Your answer should be very brief. 1.03. What is the difference between the highest and the second highest Number of enrolments of both sexes in Primary?
Keep it short and to the point. 7069. What is the difference between the highest and the second highest Number of enrolments of both sexes in Secondary?
Your answer should be compact. 956. What is the difference between the highest and the second highest Number of enrolments of both sexes in Secondary general?
Provide a succinct answer. 902. What is the difference between the highest and the second highest Number of enrolments of both sexes of Secondary vocational?
Your answer should be very brief. 231. What is the difference between the highest and the lowest Number of enrolments of both sexes of Primary?
Your answer should be very brief. 1.86e+04. What is the difference between the highest and the lowest Number of enrolments of both sexes in Secondary?
Your answer should be compact. 2.64e+04. What is the difference between the highest and the lowest Number of enrolments of both sexes of Secondary general?
Give a very brief answer. 2.44e+04. What is the difference between the highest and the lowest Number of enrolments of both sexes in Secondary vocational?
Offer a terse response. 1.96e+04. 